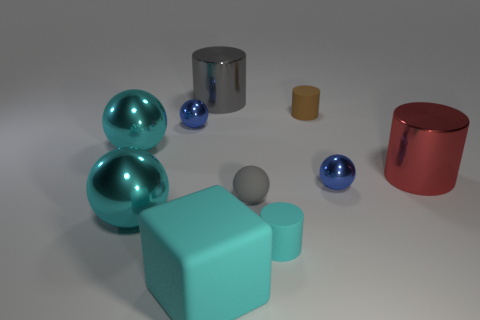What shapes are present in the image and which is the most predominant? The image contains spheres, cylinders, and cubes. The most predominant shape seems to be the sphere, as the three spherical objects immediately draw attention due to their size and reflective surface. 